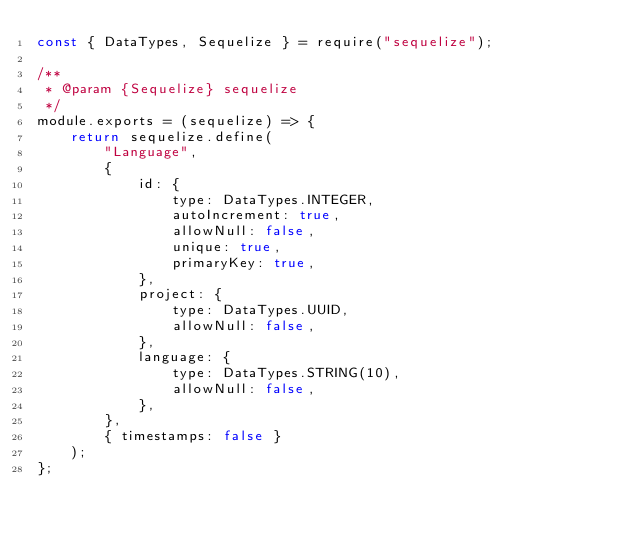<code> <loc_0><loc_0><loc_500><loc_500><_JavaScript_>const { DataTypes, Sequelize } = require("sequelize");

/**
 * @param {Sequelize} sequelize
 */
module.exports = (sequelize) => {
    return sequelize.define(
        "Language",
        {
            id: {
                type: DataTypes.INTEGER,
                autoIncrement: true,
                allowNull: false,
                unique: true,
                primaryKey: true,
            },
            project: {
                type: DataTypes.UUID,
                allowNull: false,
            },
            language: {
                type: DataTypes.STRING(10),
                allowNull: false,
            },
        },
        { timestamps: false }
    );
};
</code> 